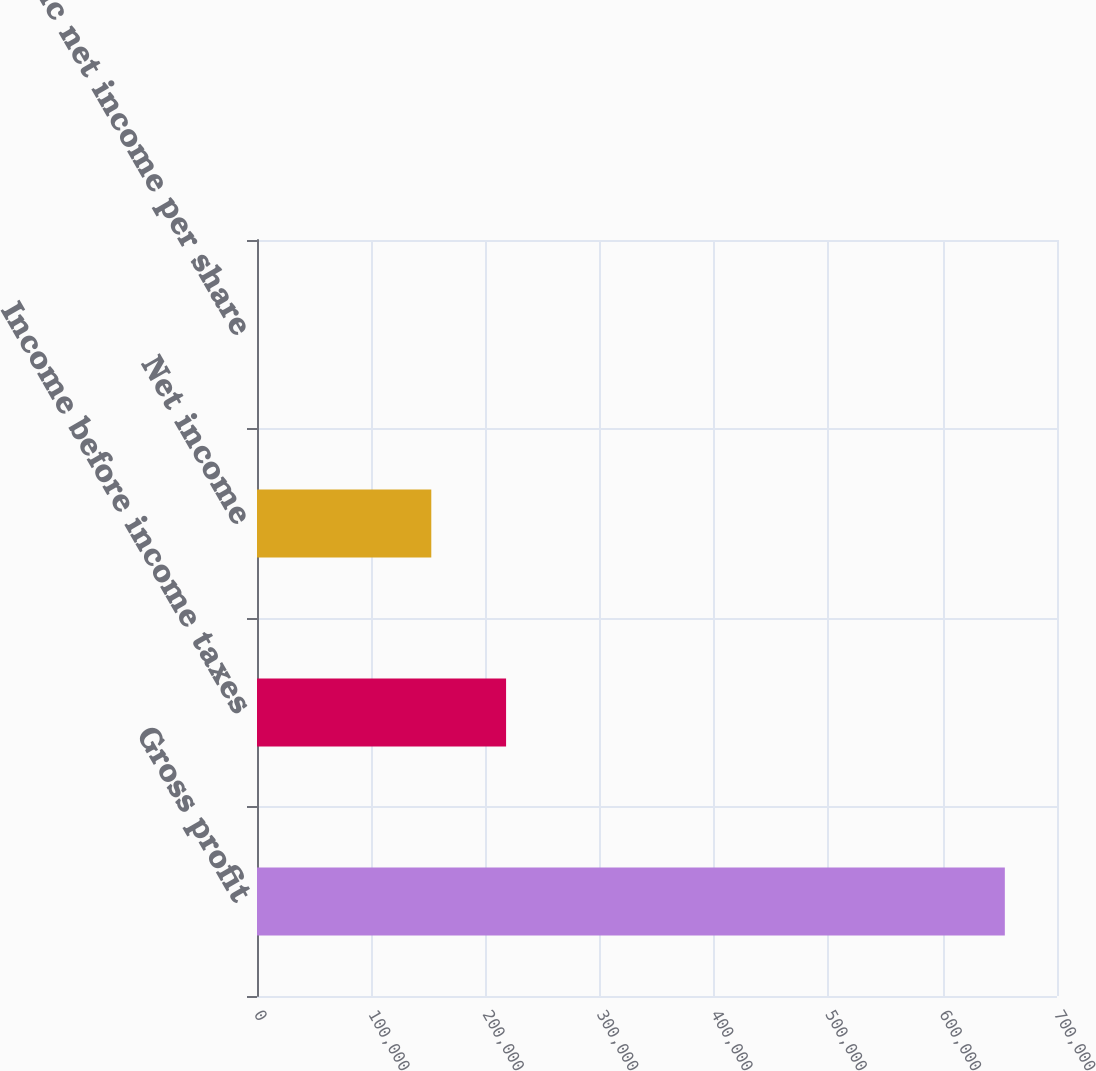Convert chart. <chart><loc_0><loc_0><loc_500><loc_500><bar_chart><fcel>Gross profit<fcel>Income before income taxes<fcel>Net income<fcel>Basic net income per share<nl><fcel>654363<fcel>217941<fcel>152505<fcel>0.26<nl></chart> 